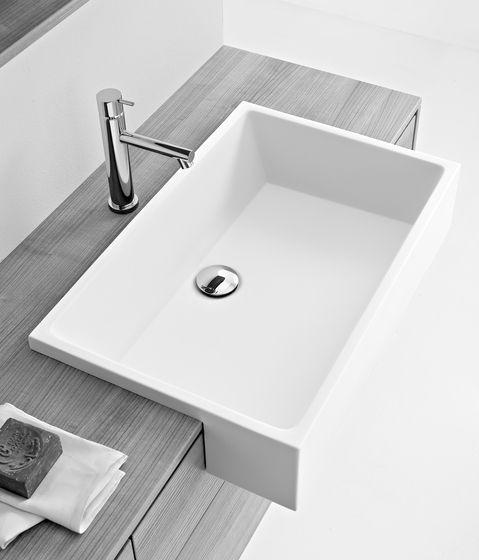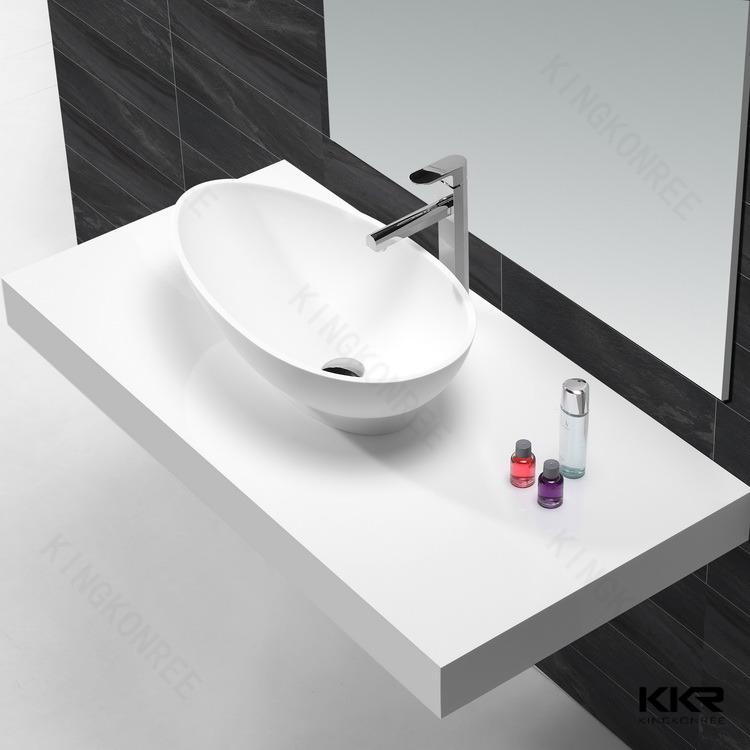The first image is the image on the left, the second image is the image on the right. Analyze the images presented: Is the assertion "The two images show a somewhat round bowl sink and a rectangular inset sink." valid? Answer yes or no. Yes. 